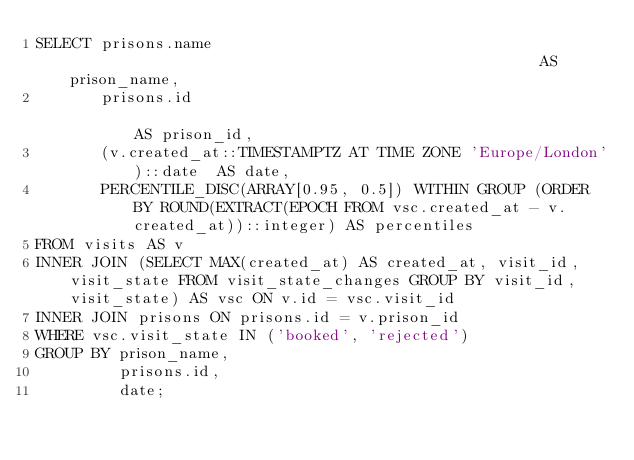<code> <loc_0><loc_0><loc_500><loc_500><_SQL_>SELECT prisons.name                                                    AS prison_name,
       prisons.id                                                      AS prison_id,
       (v.created_at::TIMESTAMPTZ AT TIME ZONE 'Europe/London')::date  AS date,
       PERCENTILE_DISC(ARRAY[0.95, 0.5]) WITHIN GROUP (ORDER BY ROUND(EXTRACT(EPOCH FROM vsc.created_at - v.created_at))::integer) AS percentiles
FROM visits AS v
INNER JOIN (SELECT MAX(created_at) AS created_at, visit_id, visit_state FROM visit_state_changes GROUP BY visit_id, visit_state) AS vsc ON v.id = vsc.visit_id
INNER JOIN prisons ON prisons.id = v.prison_id
WHERE vsc.visit_state IN ('booked', 'rejected')
GROUP BY prison_name,
         prisons.id,
         date;
</code> 